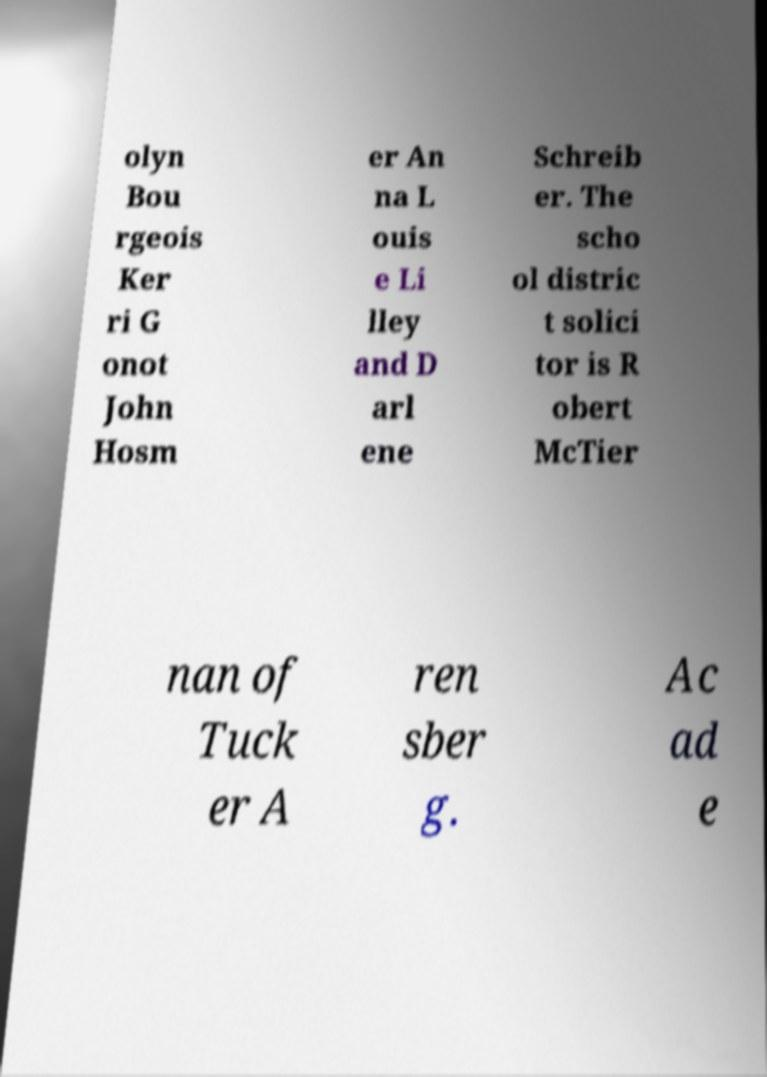I need the written content from this picture converted into text. Can you do that? olyn Bou rgeois Ker ri G onot John Hosm er An na L ouis e Li lley and D arl ene Schreib er. The scho ol distric t solici tor is R obert McTier nan of Tuck er A ren sber g. Ac ad e 